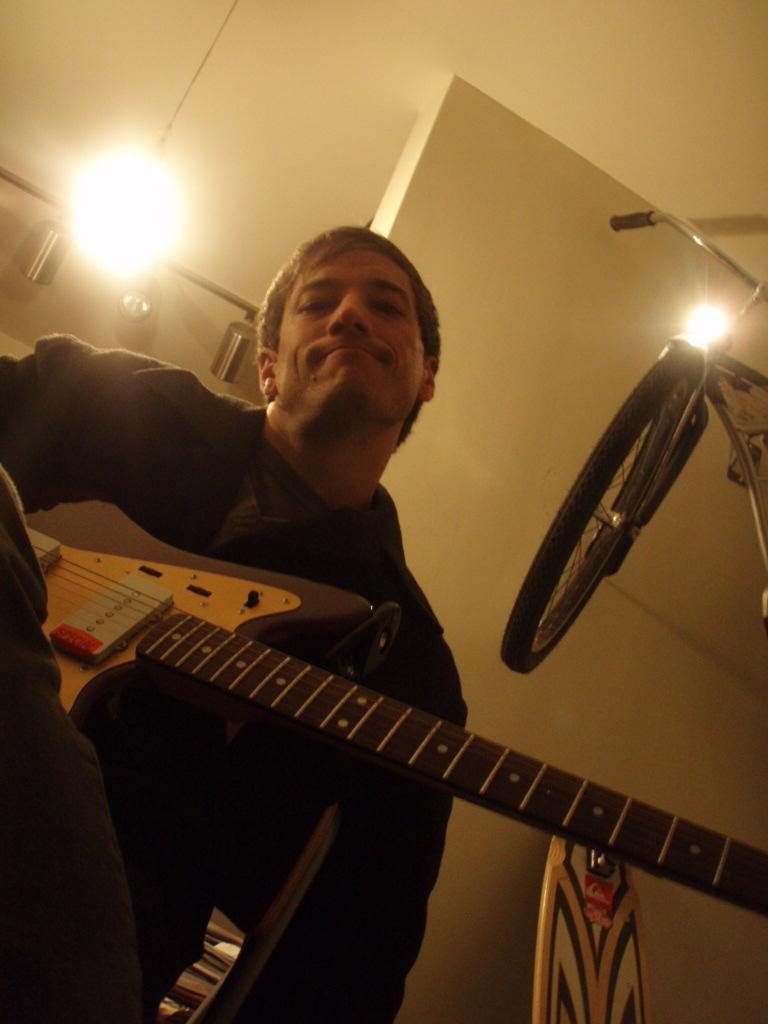How would you summarize this image in a sentence or two? In the image we can see there is a man who is standing and holding guitar in his hand. 